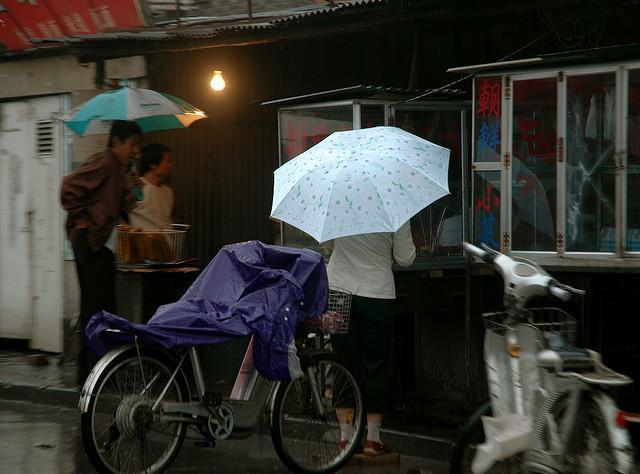How many umbrellas are there?
Give a very brief answer. 2. How many people are in the photo?
Give a very brief answer. 3. How many standing cats are there?
Give a very brief answer. 0. 